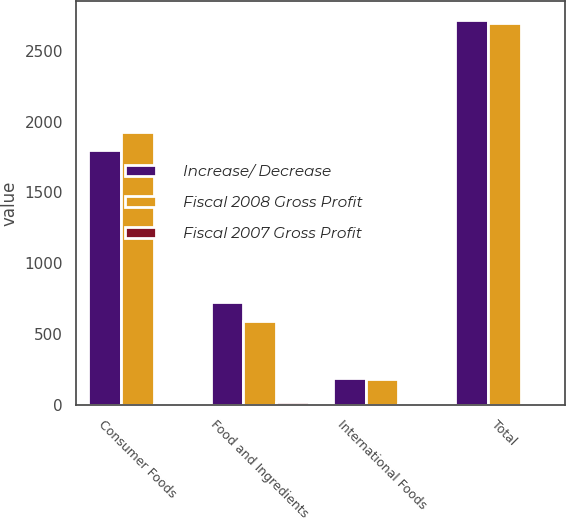<chart> <loc_0><loc_0><loc_500><loc_500><stacked_bar_chart><ecel><fcel>Consumer Foods<fcel>Food and Ingredients<fcel>International Foods<fcel>Total<nl><fcel>Increase/ Decrease<fcel>1802<fcel>724<fcel>190<fcel>2716<nl><fcel>Fiscal 2008 Gross Profit<fcel>1923<fcel>590<fcel>180<fcel>2693<nl><fcel>Fiscal 2007 Gross Profit<fcel>6<fcel>23<fcel>6<fcel>1<nl></chart> 